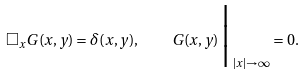Convert formula to latex. <formula><loc_0><loc_0><loc_500><loc_500>\Box _ { x } G ( x , y ) = \delta ( x , y ) , \quad G ( x , y ) \, \Big | _ { \, | x | \to \infty } = 0 .</formula> 